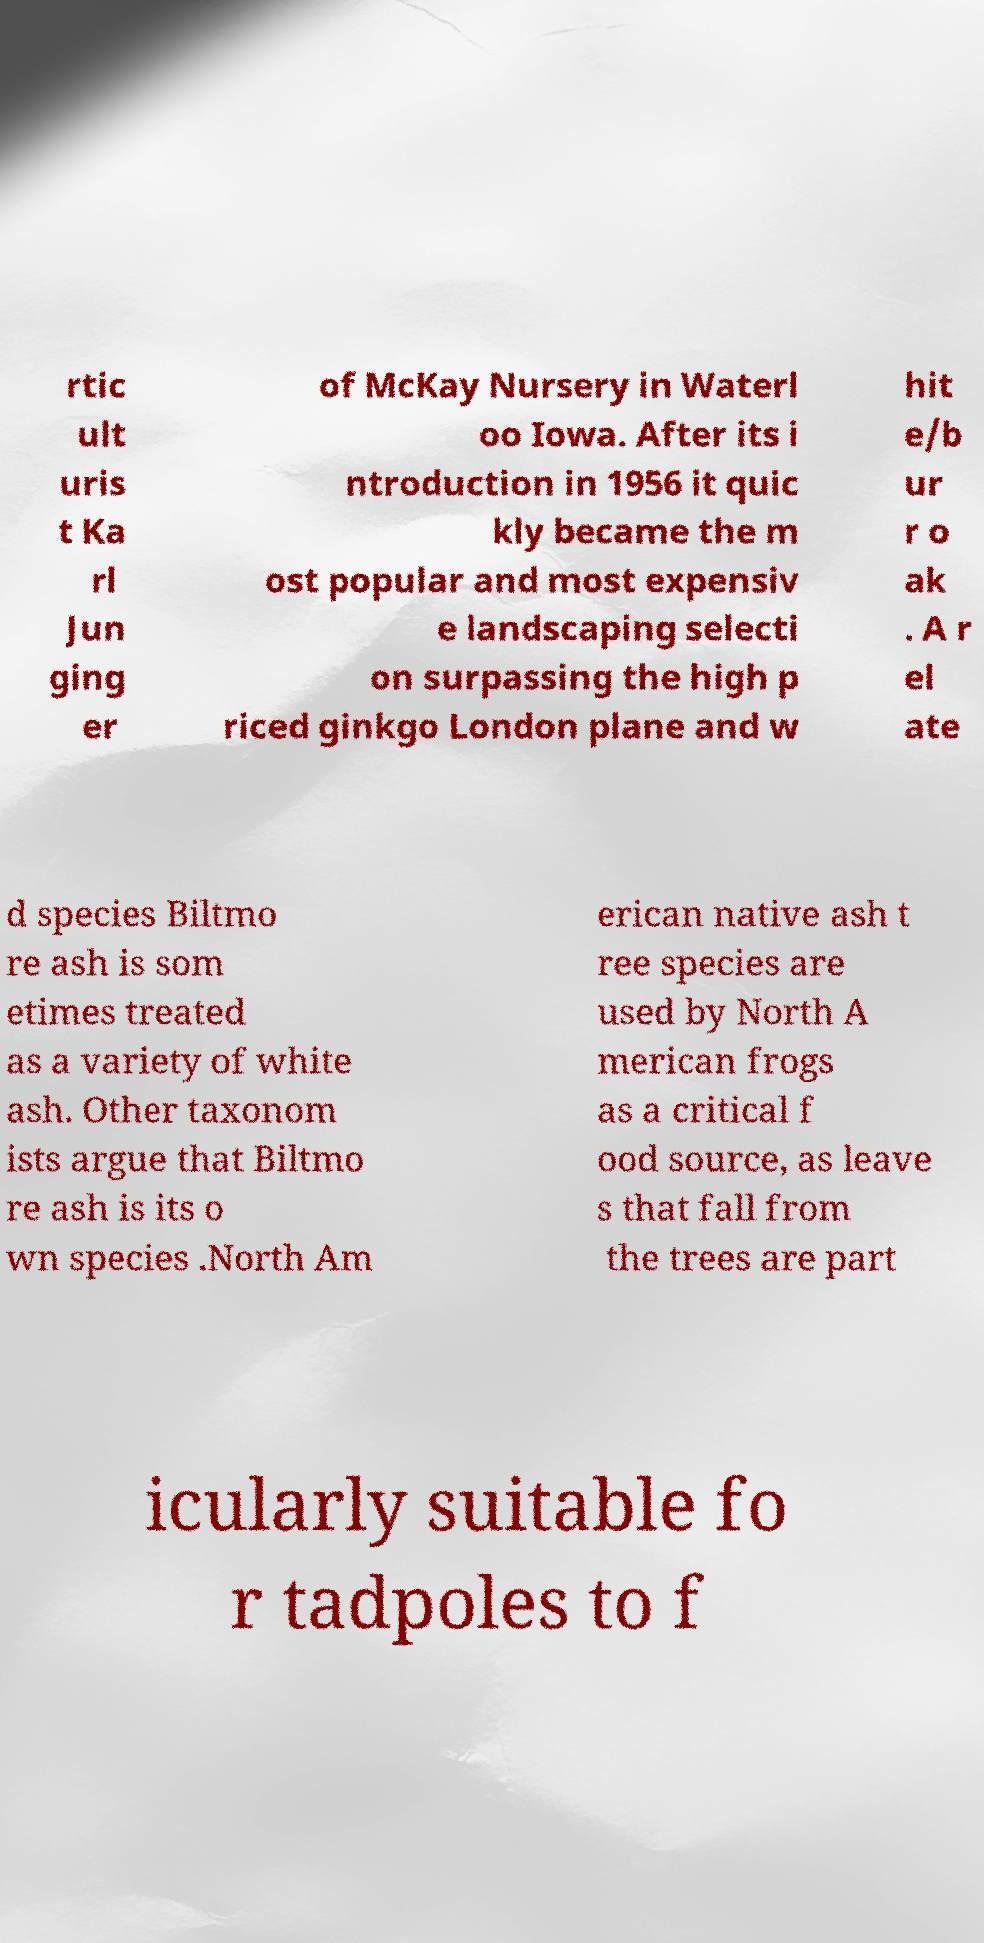Can you read and provide the text displayed in the image?This photo seems to have some interesting text. Can you extract and type it out for me? rtic ult uris t Ka rl Jun ging er of McKay Nursery in Waterl oo Iowa. After its i ntroduction in 1956 it quic kly became the m ost popular and most expensiv e landscaping selecti on surpassing the high p riced ginkgo London plane and w hit e/b ur r o ak . A r el ate d species Biltmo re ash is som etimes treated as a variety of white ash. Other taxonom ists argue that Biltmo re ash is its o wn species .North Am erican native ash t ree species are used by North A merican frogs as a critical f ood source, as leave s that fall from the trees are part icularly suitable fo r tadpoles to f 